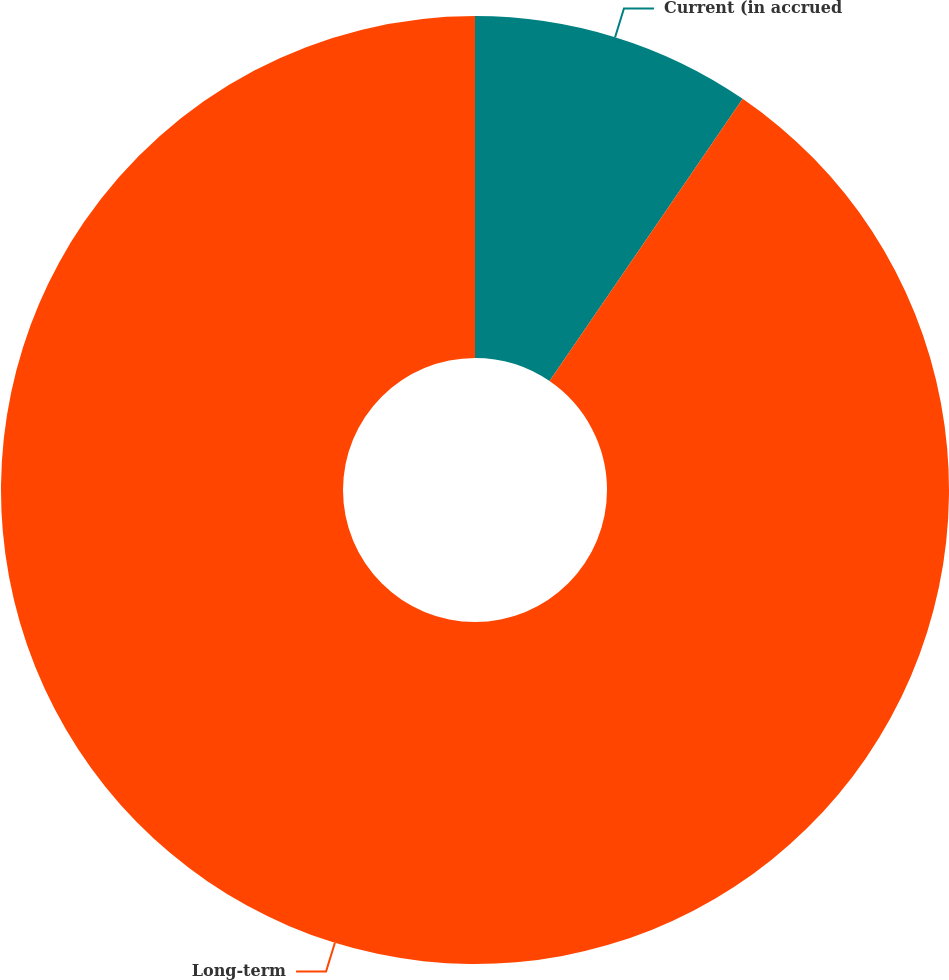<chart> <loc_0><loc_0><loc_500><loc_500><pie_chart><fcel>Current (in accrued<fcel>Long-term<nl><fcel>9.55%<fcel>90.45%<nl></chart> 